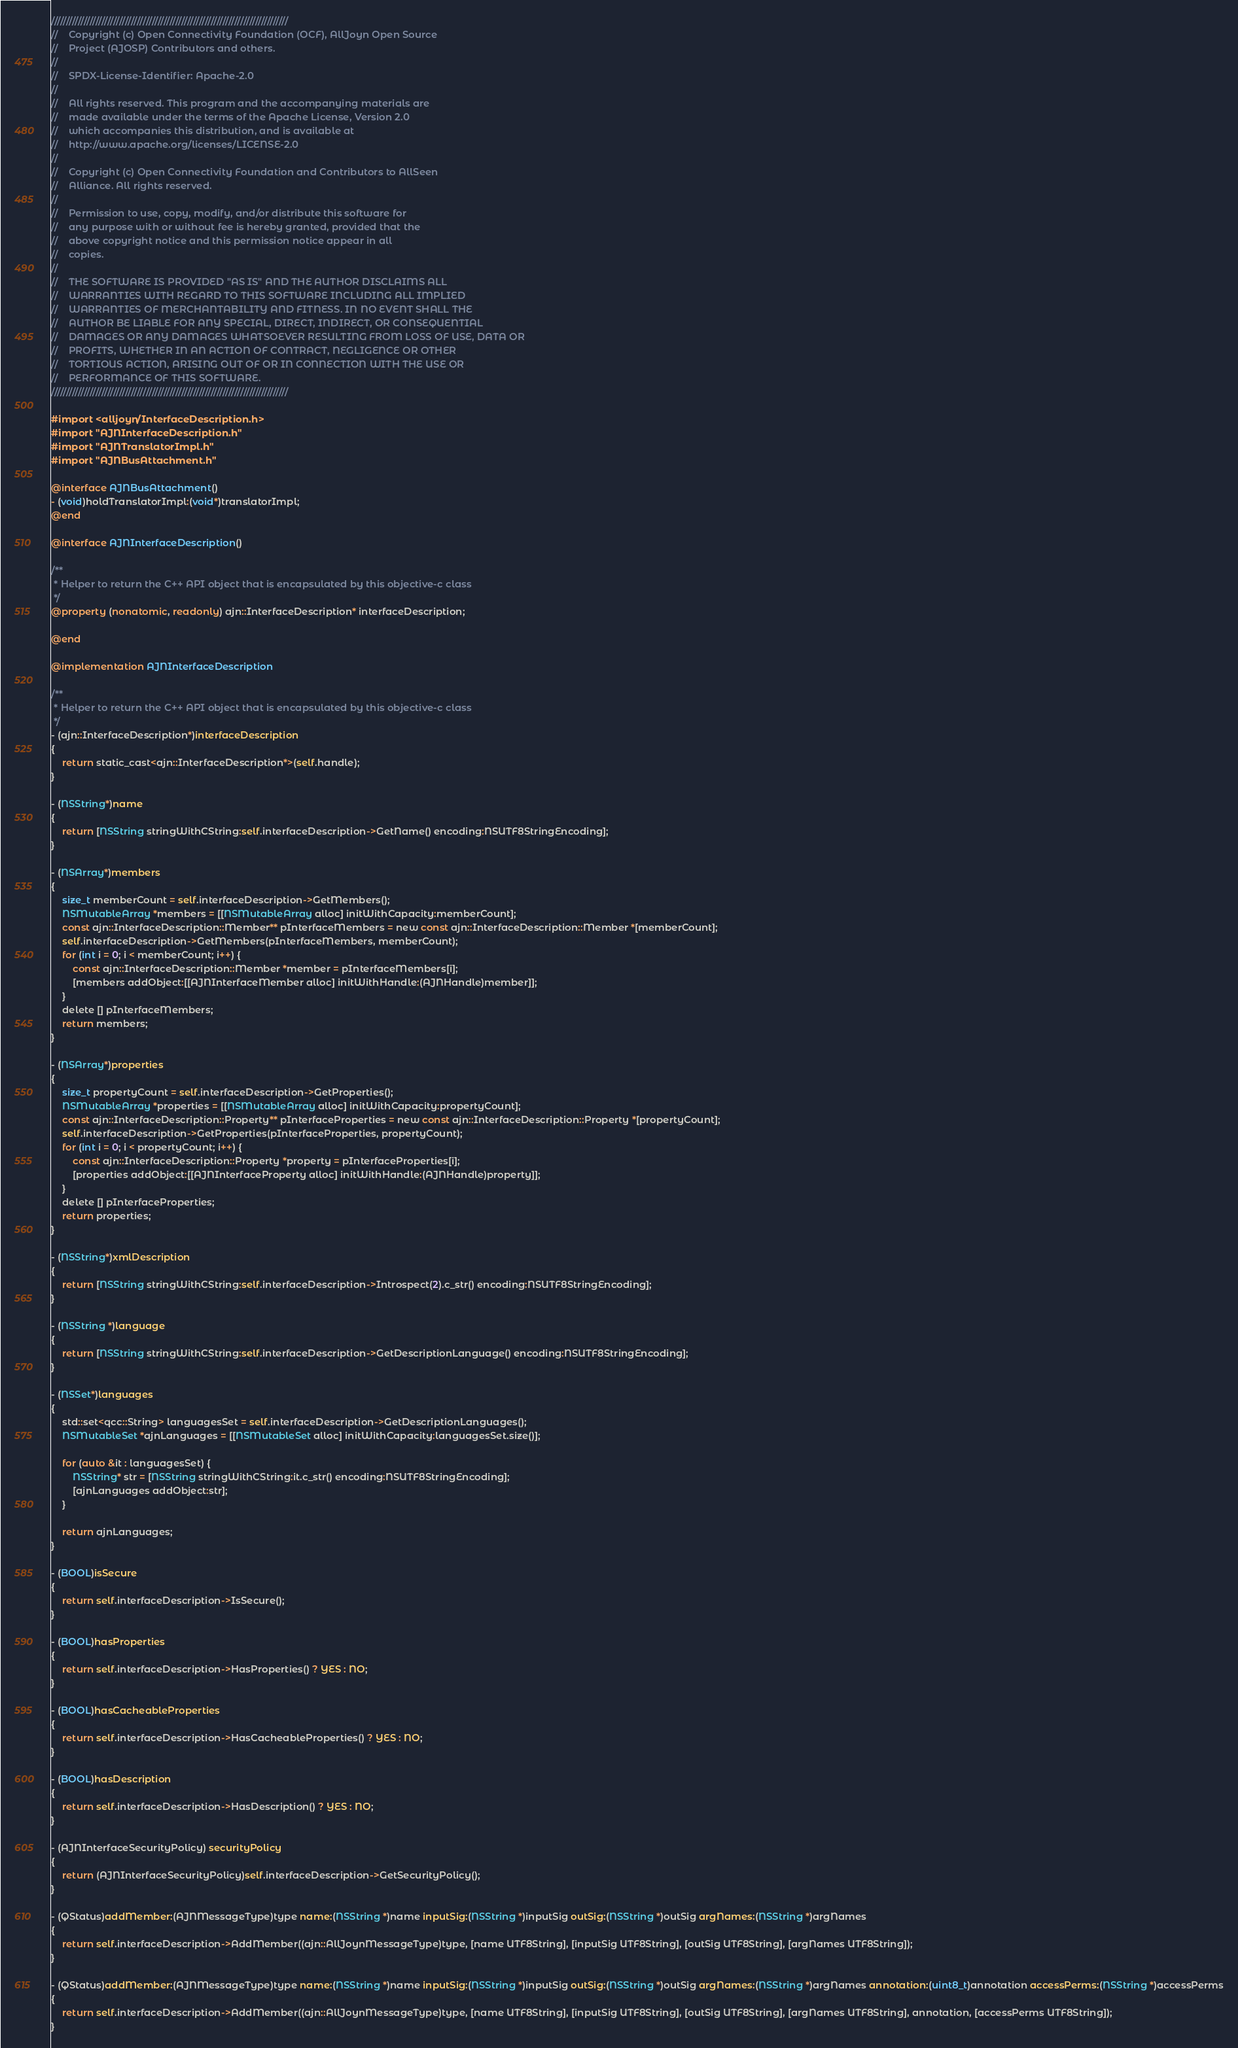<code> <loc_0><loc_0><loc_500><loc_500><_ObjectiveC_>////////////////////////////////////////////////////////////////////////////////
//    Copyright (c) Open Connectivity Foundation (OCF), AllJoyn Open Source
//    Project (AJOSP) Contributors and others.
//
//    SPDX-License-Identifier: Apache-2.0
//
//    All rights reserved. This program and the accompanying materials are
//    made available under the terms of the Apache License, Version 2.0
//    which accompanies this distribution, and is available at
//    http://www.apache.org/licenses/LICENSE-2.0
//
//    Copyright (c) Open Connectivity Foundation and Contributors to AllSeen
//    Alliance. All rights reserved.
//
//    Permission to use, copy, modify, and/or distribute this software for
//    any purpose with or without fee is hereby granted, provided that the
//    above copyright notice and this permission notice appear in all
//    copies.
//
//    THE SOFTWARE IS PROVIDED "AS IS" AND THE AUTHOR DISCLAIMS ALL
//    WARRANTIES WITH REGARD TO THIS SOFTWARE INCLUDING ALL IMPLIED
//    WARRANTIES OF MERCHANTABILITY AND FITNESS. IN NO EVENT SHALL THE
//    AUTHOR BE LIABLE FOR ANY SPECIAL, DIRECT, INDIRECT, OR CONSEQUENTIAL
//    DAMAGES OR ANY DAMAGES WHATSOEVER RESULTING FROM LOSS OF USE, DATA OR
//    PROFITS, WHETHER IN AN ACTION OF CONTRACT, NEGLIGENCE OR OTHER
//    TORTIOUS ACTION, ARISING OUT OF OR IN CONNECTION WITH THE USE OR
//    PERFORMANCE OF THIS SOFTWARE.
////////////////////////////////////////////////////////////////////////////////

#import <alljoyn/InterfaceDescription.h>
#import "AJNInterfaceDescription.h"
#import "AJNTranslatorImpl.h"
#import "AJNBusAttachment.h"

@interface AJNBusAttachment()
- (void)holdTranslatorImpl:(void*)translatorImpl;
@end

@interface AJNInterfaceDescription()

/**
 * Helper to return the C++ API object that is encapsulated by this objective-c class
 */
@property (nonatomic, readonly) ajn::InterfaceDescription* interfaceDescription;

@end

@implementation AJNInterfaceDescription

/**
 * Helper to return the C++ API object that is encapsulated by this objective-c class
 */
- (ajn::InterfaceDescription*)interfaceDescription
{
    return static_cast<ajn::InterfaceDescription*>(self.handle);
}

- (NSString*)name
{
    return [NSString stringWithCString:self.interfaceDescription->GetName() encoding:NSUTF8StringEncoding];
}

- (NSArray*)members
{
    size_t memberCount = self.interfaceDescription->GetMembers();
    NSMutableArray *members = [[NSMutableArray alloc] initWithCapacity:memberCount];
    const ajn::InterfaceDescription::Member** pInterfaceMembers = new const ajn::InterfaceDescription::Member *[memberCount];
    self.interfaceDescription->GetMembers(pInterfaceMembers, memberCount);
    for (int i = 0; i < memberCount; i++) {
        const ajn::InterfaceDescription::Member *member = pInterfaceMembers[i];
        [members addObject:[[AJNInterfaceMember alloc] initWithHandle:(AJNHandle)member]];
    }
    delete [] pInterfaceMembers;
    return members;
}

- (NSArray*)properties
{
    size_t propertyCount = self.interfaceDescription->GetProperties();
    NSMutableArray *properties = [[NSMutableArray alloc] initWithCapacity:propertyCount];
    const ajn::InterfaceDescription::Property** pInterfaceProperties = new const ajn::InterfaceDescription::Property *[propertyCount];
    self.interfaceDescription->GetProperties(pInterfaceProperties, propertyCount);
    for (int i = 0; i < propertyCount; i++) {
        const ajn::InterfaceDescription::Property *property = pInterfaceProperties[i];
        [properties addObject:[[AJNInterfaceProperty alloc] initWithHandle:(AJNHandle)property]];
    }
    delete [] pInterfaceProperties;
    return properties;
}

- (NSString*)xmlDescription
{
    return [NSString stringWithCString:self.interfaceDescription->Introspect(2).c_str() encoding:NSUTF8StringEncoding];
}

- (NSString *)language
{
    return [NSString stringWithCString:self.interfaceDescription->GetDescriptionLanguage() encoding:NSUTF8StringEncoding];
}

- (NSSet*)languages
{
    std::set<qcc::String> languagesSet = self.interfaceDescription->GetDescriptionLanguages();
    NSMutableSet *ajnLanguages = [[NSMutableSet alloc] initWithCapacity:languagesSet.size()];

    for (auto &it : languagesSet) {
        NSString* str = [NSString stringWithCString:it.c_str() encoding:NSUTF8StringEncoding];
        [ajnLanguages addObject:str];
    }

    return ajnLanguages;
}

- (BOOL)isSecure
{
    return self.interfaceDescription->IsSecure();
}

- (BOOL)hasProperties
{
    return self.interfaceDescription->HasProperties() ? YES : NO;
}

- (BOOL)hasCacheableProperties
{
    return self.interfaceDescription->HasCacheableProperties() ? YES : NO;
}

- (BOOL)hasDescription
{
    return self.interfaceDescription->HasDescription() ? YES : NO;
}

- (AJNInterfaceSecurityPolicy) securityPolicy
{
    return (AJNInterfaceSecurityPolicy)self.interfaceDescription->GetSecurityPolicy();
}

- (QStatus)addMember:(AJNMessageType)type name:(NSString *)name inputSig:(NSString *)inputSig outSig:(NSString *)outSig argNames:(NSString *)argNames
{
    return self.interfaceDescription->AddMember((ajn::AllJoynMessageType)type, [name UTF8String], [inputSig UTF8String], [outSig UTF8String], [argNames UTF8String]);
}

- (QStatus)addMember:(AJNMessageType)type name:(NSString *)name inputSig:(NSString *)inputSig outSig:(NSString *)outSig argNames:(NSString *)argNames annotation:(uint8_t)annotation accessPerms:(NSString *)accessPerms
{
    return self.interfaceDescription->AddMember((ajn::AllJoynMessageType)type, [name UTF8String], [inputSig UTF8String], [outSig UTF8String], [argNames UTF8String], annotation, [accessPerms UTF8String]);
}
</code> 